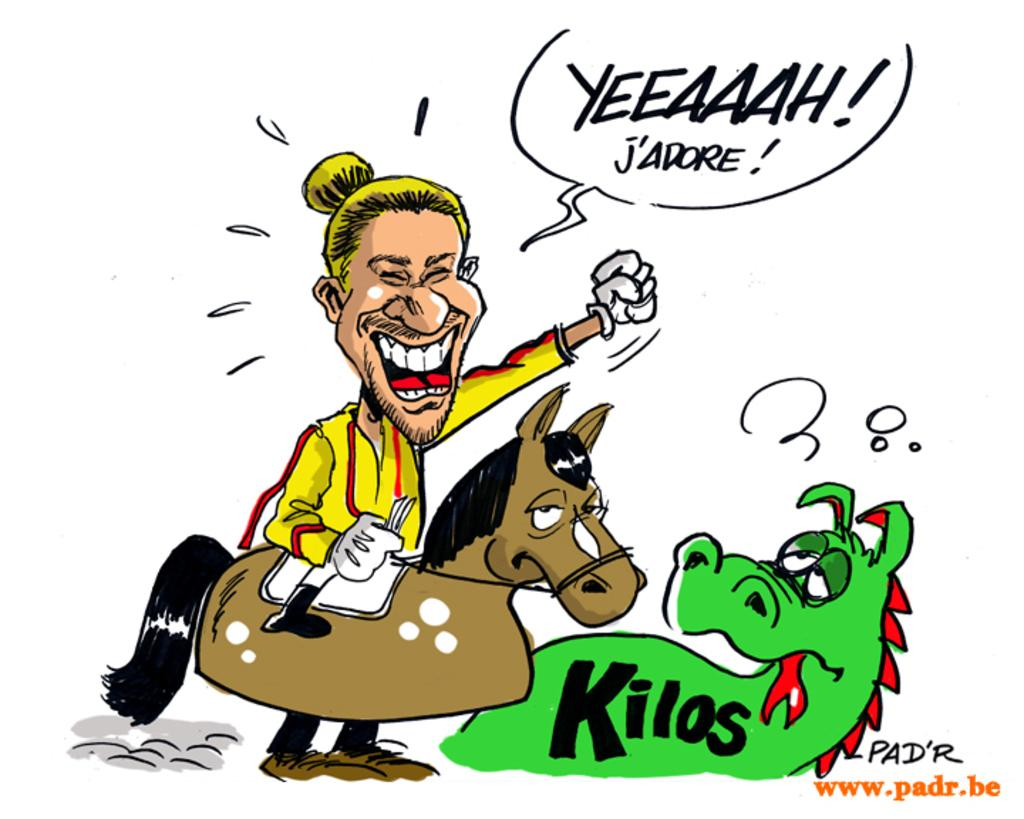What is the main subject of the image? There is a depiction of a person in the image. What other living beings are present in the image? There are animals depicted in the image. Is there any written information in the image? Yes, there is text present in the image. What is the color of the background in the image? The background of the image is white. What type of toys can be seen in the image? There is no mention of toys in the image; it features a person, animals, and text on a white background. 